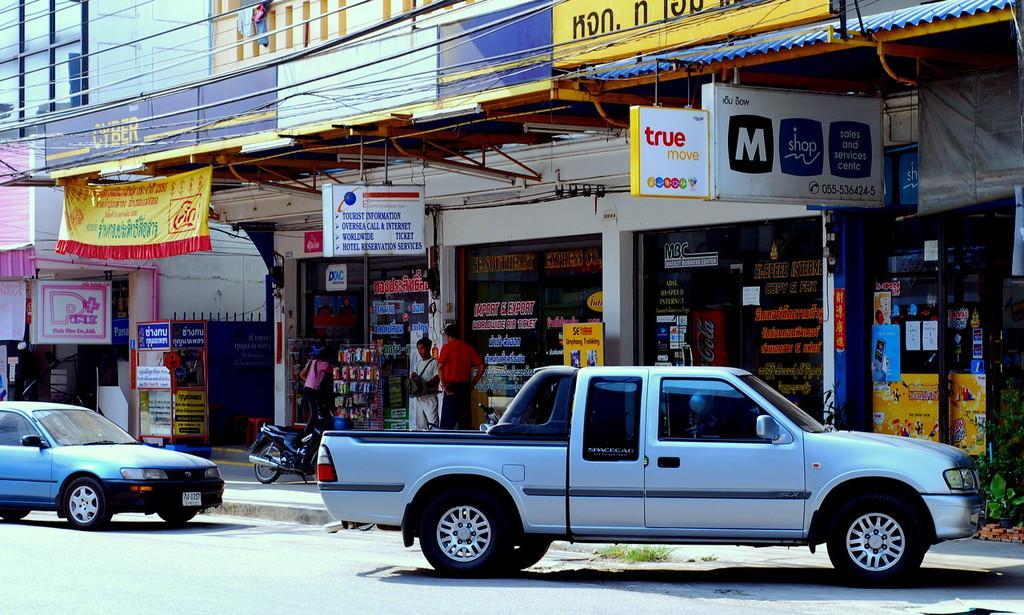Please provide a concise description of this image. These are the two cars that are parked on the road and there are stores in this image. 